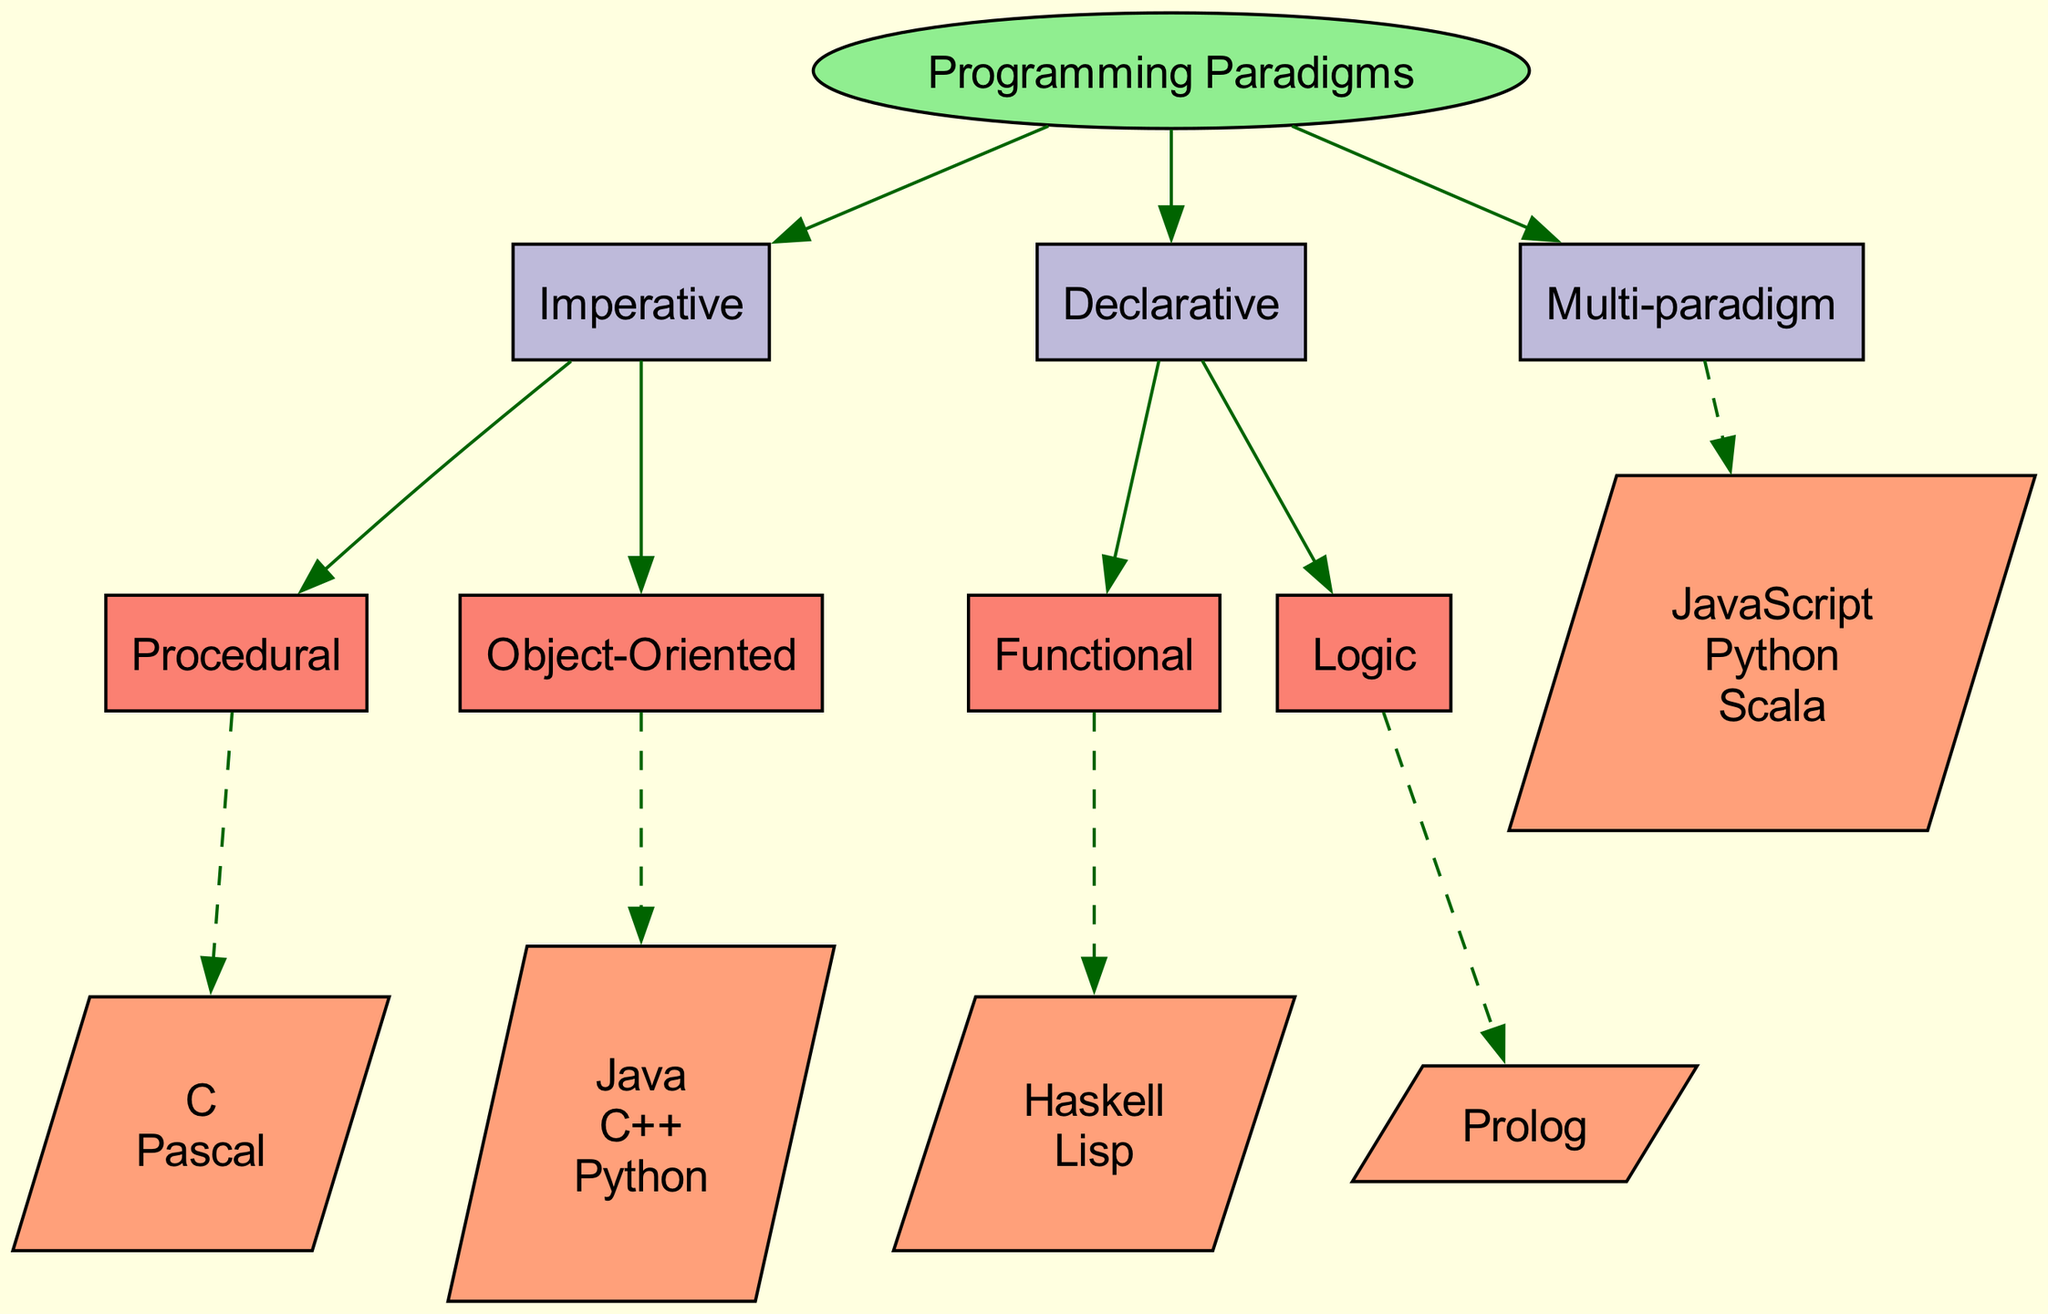What is the root of the diagram? The root node of the diagram is labeled as "Programming Paradigms," which represents the highest level of categorization in this hierarchical tree structure.
Answer: Programming Paradigms How many main programming paradigms are shown? The diagram showcases three main programming paradigms: Imperative, Declarative, and Multi-paradigm. Counting these gives us a total of three paradigms.
Answer: 3 Which programming language is associated with Object-Oriented? The Object-Oriented paradigm includes the languages Java, C++, and Python. Any of these can answer the question, but the first one mentioned is Java.
Answer: Java What type of programming paradigm is Haskell categorized under? Haskell is listed as a language under the Functional paradigm, which is a subtype of the Declarative programming paradigm, indicating its classification.
Answer: Functional How many languages are associated with the Imperative paradigm? Within the Imperative paradigm, there are two subcategories: Procedural (C, Pascal) and Object-Oriented (Java, C++, Python). Counting all unique languages gives us a total of five (C, Pascal, Java, C++, Python).
Answer: 5 Which programming paradigm has the programming language Prolog? Prolog is categorized under the Logic paradigm, which is a subset of the Declarative programming paradigm, linking it specifically to this programming approach.
Answer: Declarative Which paradigm includes the most programming languages? Among the paradigms illustrated, the Multi-paradigm section presents three languages: JavaScript, Python, and Scala, compared to the others that present fewer options. Thus, it has the most programming languages listed.
Answer: Multi-paradigm What relationship exists between Object-Oriented and Procedural paradigms? Both Object-Oriented and Procedural paradigms are subcategories of the broader Imperative programming paradigm, showing their hierarchical relationship in the structure.
Answer: Subcategories How many edges emanate from the Declarative node? There are two edges that lead from the Declarative node to its two subcategories: Functional and Logic, indicating the direct connections from this paradigm to its respective types.
Answer: 2 